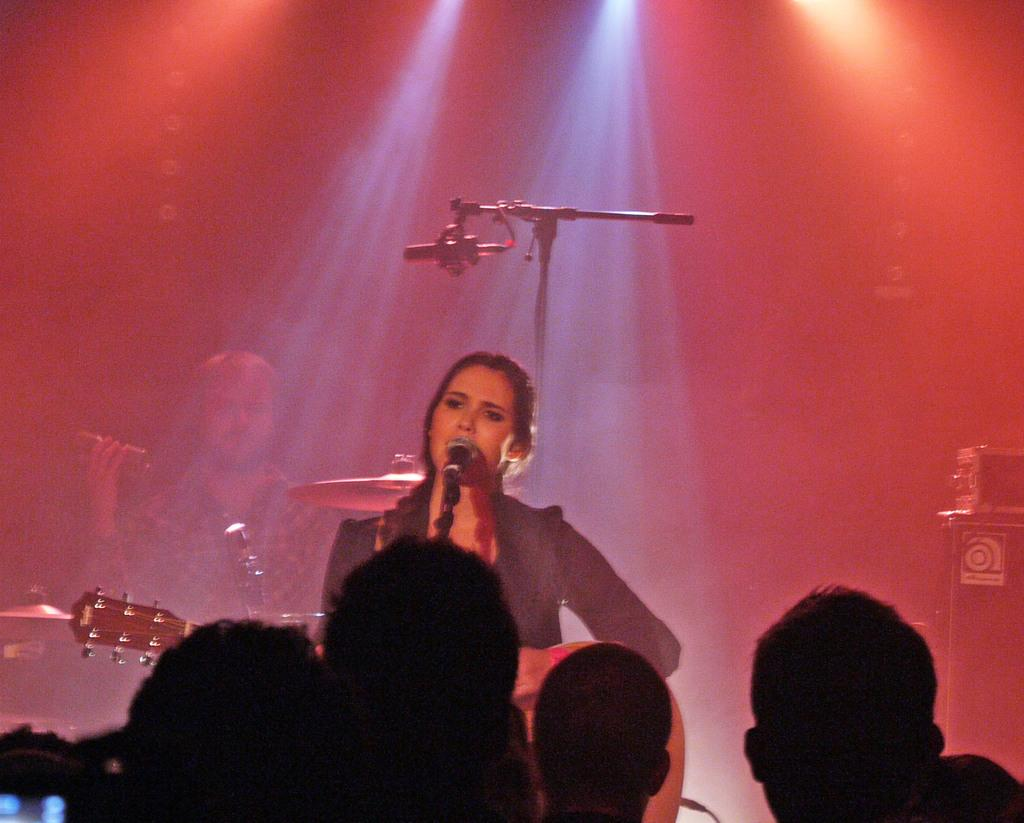What is happening in the image? There are people in the image, and a woman is holding a guitar and singing on a mic, while a man is playing musical drums. What instrument is the woman holding? The woman is holding a guitar. What is the man doing in the image? The man is playing musical drums. What type of love can be seen in the image? There is no specific type of love depicted in the image; it features people playing musical instruments. How does the balance of the drummer affect the performance in the image? There is no mention of balance in the image, as it focuses on the people playing musical instruments. 